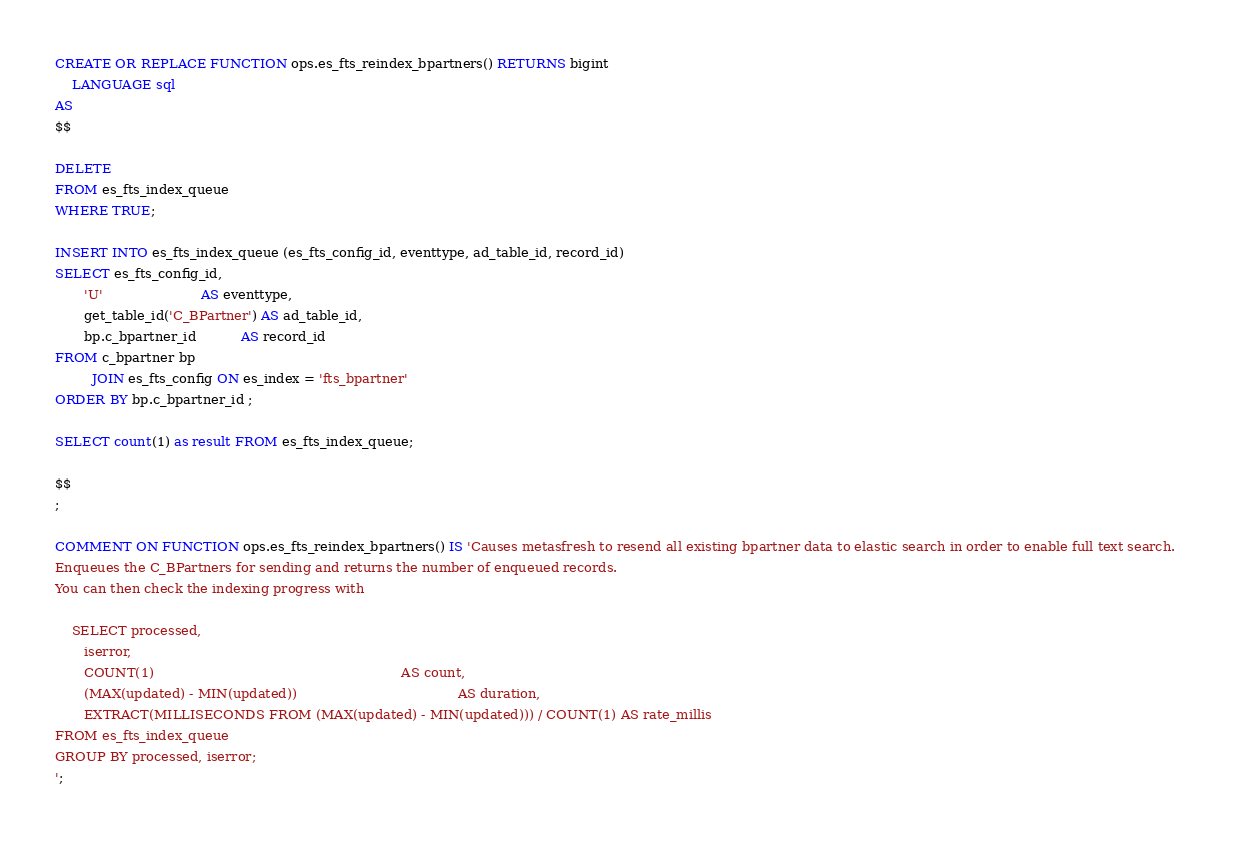<code> <loc_0><loc_0><loc_500><loc_500><_SQL_>
CREATE OR REPLACE FUNCTION ops.es_fts_reindex_bpartners() RETURNS bigint
    LANGUAGE sql
AS
$$

DELETE
FROM es_fts_index_queue
WHERE TRUE;

INSERT INTO es_fts_index_queue (es_fts_config_id, eventtype, ad_table_id, record_id)
SELECT es_fts_config_id,
       'U'                        AS eventtype,
       get_table_id('C_BPartner') AS ad_table_id,
       bp.c_bpartner_id           AS record_id
FROM c_bpartner bp
         JOIN es_fts_config ON es_index = 'fts_bpartner'
ORDER BY bp.c_bpartner_id ;

SELECT count(1) as result FROM es_fts_index_queue;

$$
;

COMMENT ON FUNCTION ops.es_fts_reindex_bpartners() IS 'Causes metasfresh to resend all existing bpartner data to elastic search in order to enable full text search. 
Enqueues the C_BPartners for sending and returns the number of enqueued records.
You can then check the indexing progress with 

    SELECT processed,
       iserror,
       COUNT(1)                                                            AS count,
       (MAX(updated) - MIN(updated))                                       AS duration,
       EXTRACT(MILLISECONDS FROM (MAX(updated) - MIN(updated))) / COUNT(1) AS rate_millis
FROM es_fts_index_queue
GROUP BY processed, iserror;
';
</code> 